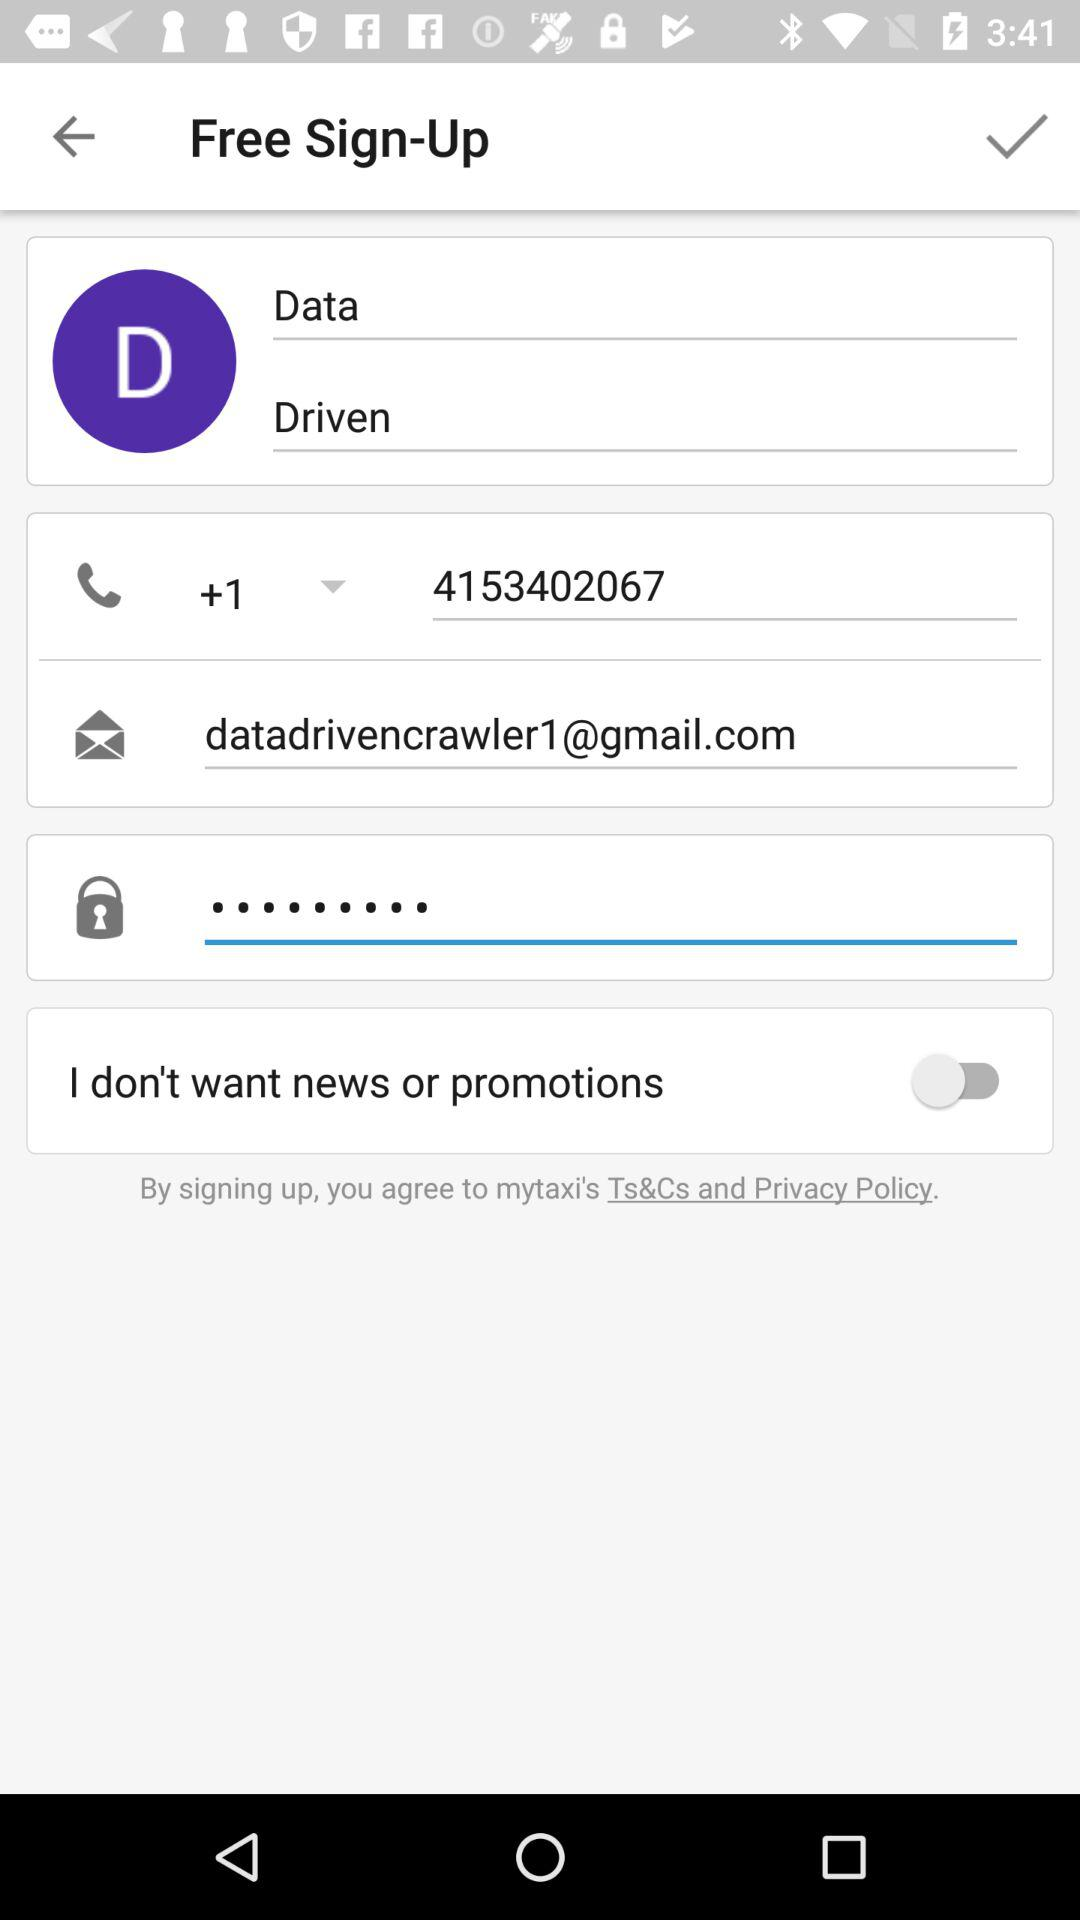What is the charge for signing up? Signing up is free. 